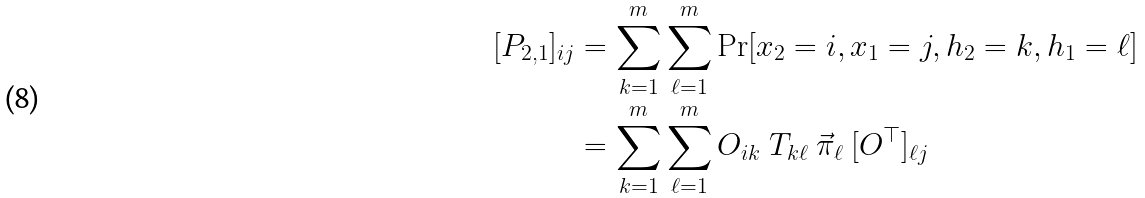<formula> <loc_0><loc_0><loc_500><loc_500>[ P _ { 2 , 1 } ] _ { i j } & = \sum _ { k = 1 } ^ { m } \sum _ { \ell = 1 } ^ { m } \Pr [ x _ { 2 } = i , x _ { 1 } = j , h _ { 2 } = k , h _ { 1 } = \ell ] \\ & = \sum _ { k = 1 } ^ { m } \sum _ { \ell = 1 } ^ { m } O _ { i k } \ T _ { k \ell } \ \vec { \pi } _ { \ell } \ [ O ^ { \top } ] _ { \ell j }</formula> 